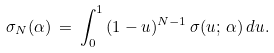Convert formula to latex. <formula><loc_0><loc_0><loc_500><loc_500>\sigma _ { N } ( \alpha ) \, = \, \int _ { 0 } ^ { 1 } \, ( 1 - u ) ^ { N - 1 } \, \sigma ( u ; \, \alpha ) \, d u .</formula> 